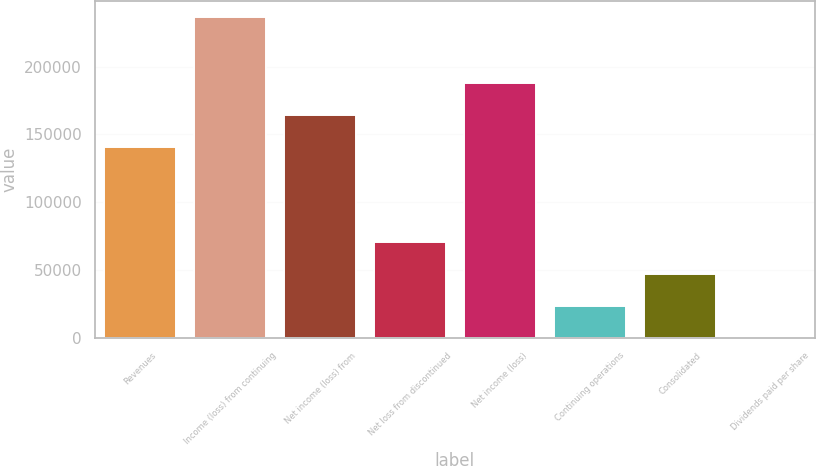<chart> <loc_0><loc_0><loc_500><loc_500><bar_chart><fcel>Revenues<fcel>Income (loss) from continuing<fcel>Net income (loss) from<fcel>Net loss from discontinued<fcel>Net income (loss)<fcel>Continuing operations<fcel>Consolidated<fcel>Dividends paid per share<nl><fcel>140854<fcel>236265<fcel>164480<fcel>70879.7<fcel>188107<fcel>23626.7<fcel>47253.2<fcel>0.24<nl></chart> 